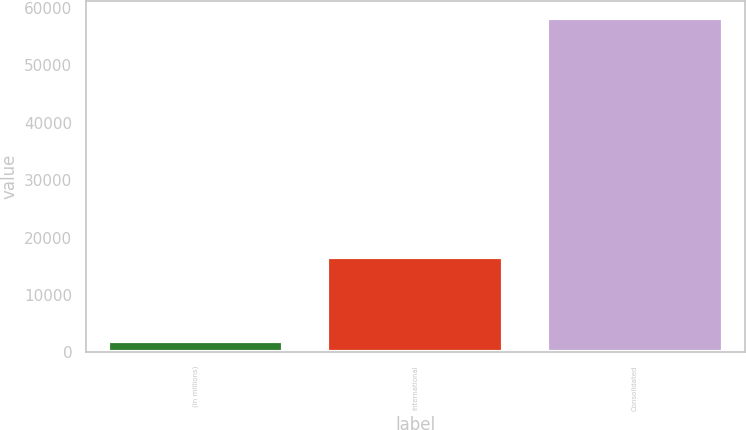Convert chart to OTSL. <chart><loc_0><loc_0><loc_500><loc_500><bar_chart><fcel>(in millions)<fcel>International<fcel>Consolidated<nl><fcel>2015<fcel>16647<fcel>58327<nl></chart> 